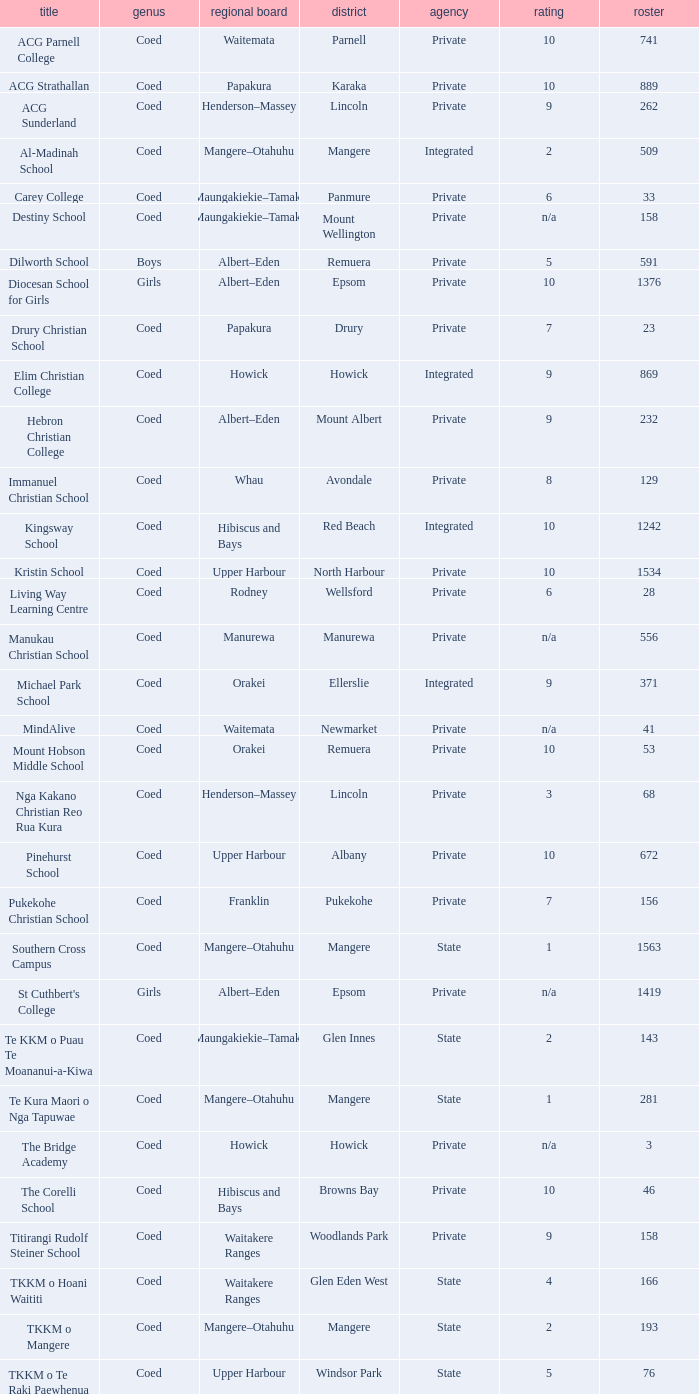What name shows as private authority and hibiscus and bays local board ? The Corelli School. 